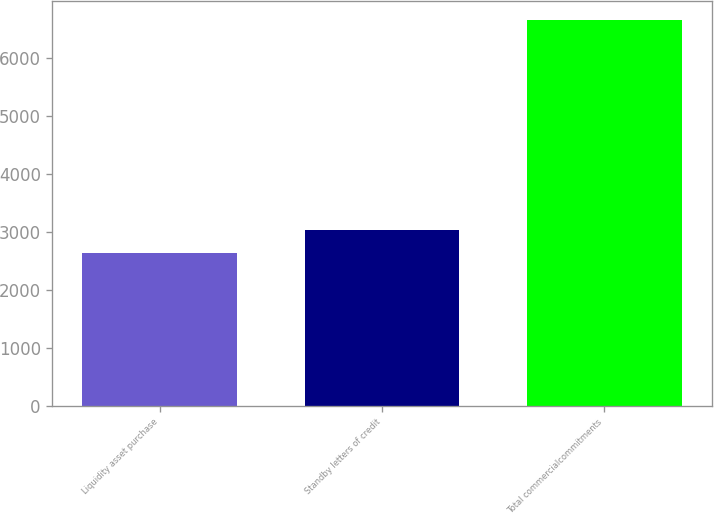Convert chart to OTSL. <chart><loc_0><loc_0><loc_500><loc_500><bar_chart><fcel>Liquidity asset purchase<fcel>Standby letters of credit<fcel>Total commercialcommitments<nl><fcel>2638<fcel>3039.8<fcel>6656<nl></chart> 